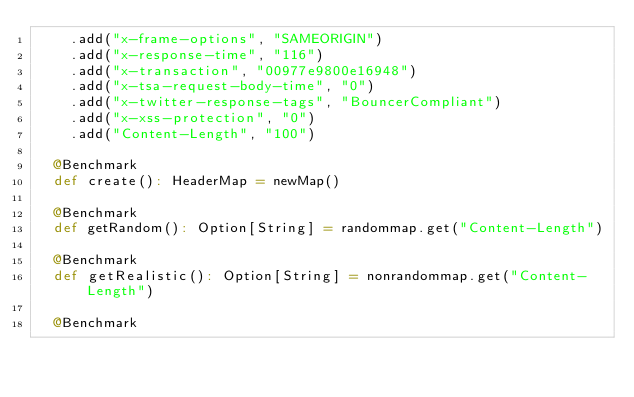Convert code to text. <code><loc_0><loc_0><loc_500><loc_500><_Scala_>    .add("x-frame-options", "SAMEORIGIN")
    .add("x-response-time", "116")
    .add("x-transaction", "00977e9800e16948")
    .add("x-tsa-request-body-time", "0")
    .add("x-twitter-response-tags", "BouncerCompliant")
    .add("x-xss-protection", "0")
    .add("Content-Length", "100")

  @Benchmark
  def create(): HeaderMap = newMap()

  @Benchmark
  def getRandom(): Option[String] = randommap.get("Content-Length")

  @Benchmark
  def getRealistic(): Option[String] = nonrandommap.get("Content-Length")

  @Benchmark</code> 